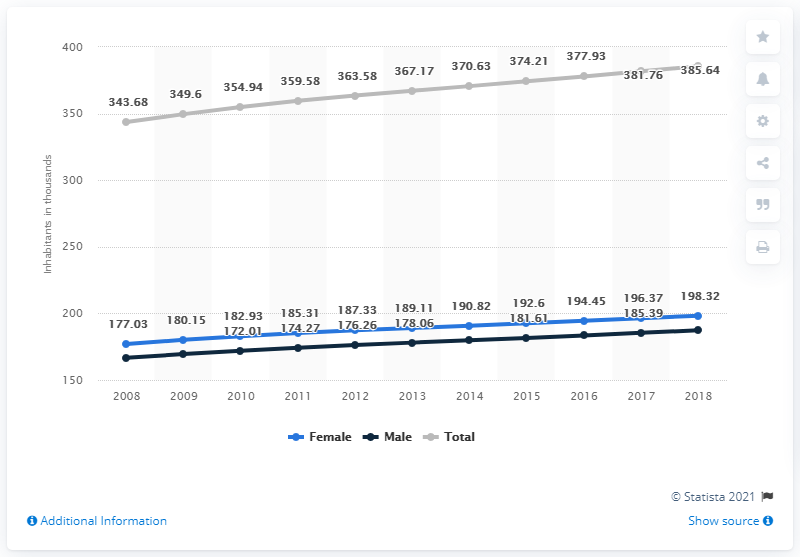What's the value of total population increased from 2016 to 2018? The total population increased by 7.71 million from 2016 to 2018. This increment reflects demographic changes over these years, possibly influenced by aspects like birth rates, immigration, and government policies. 